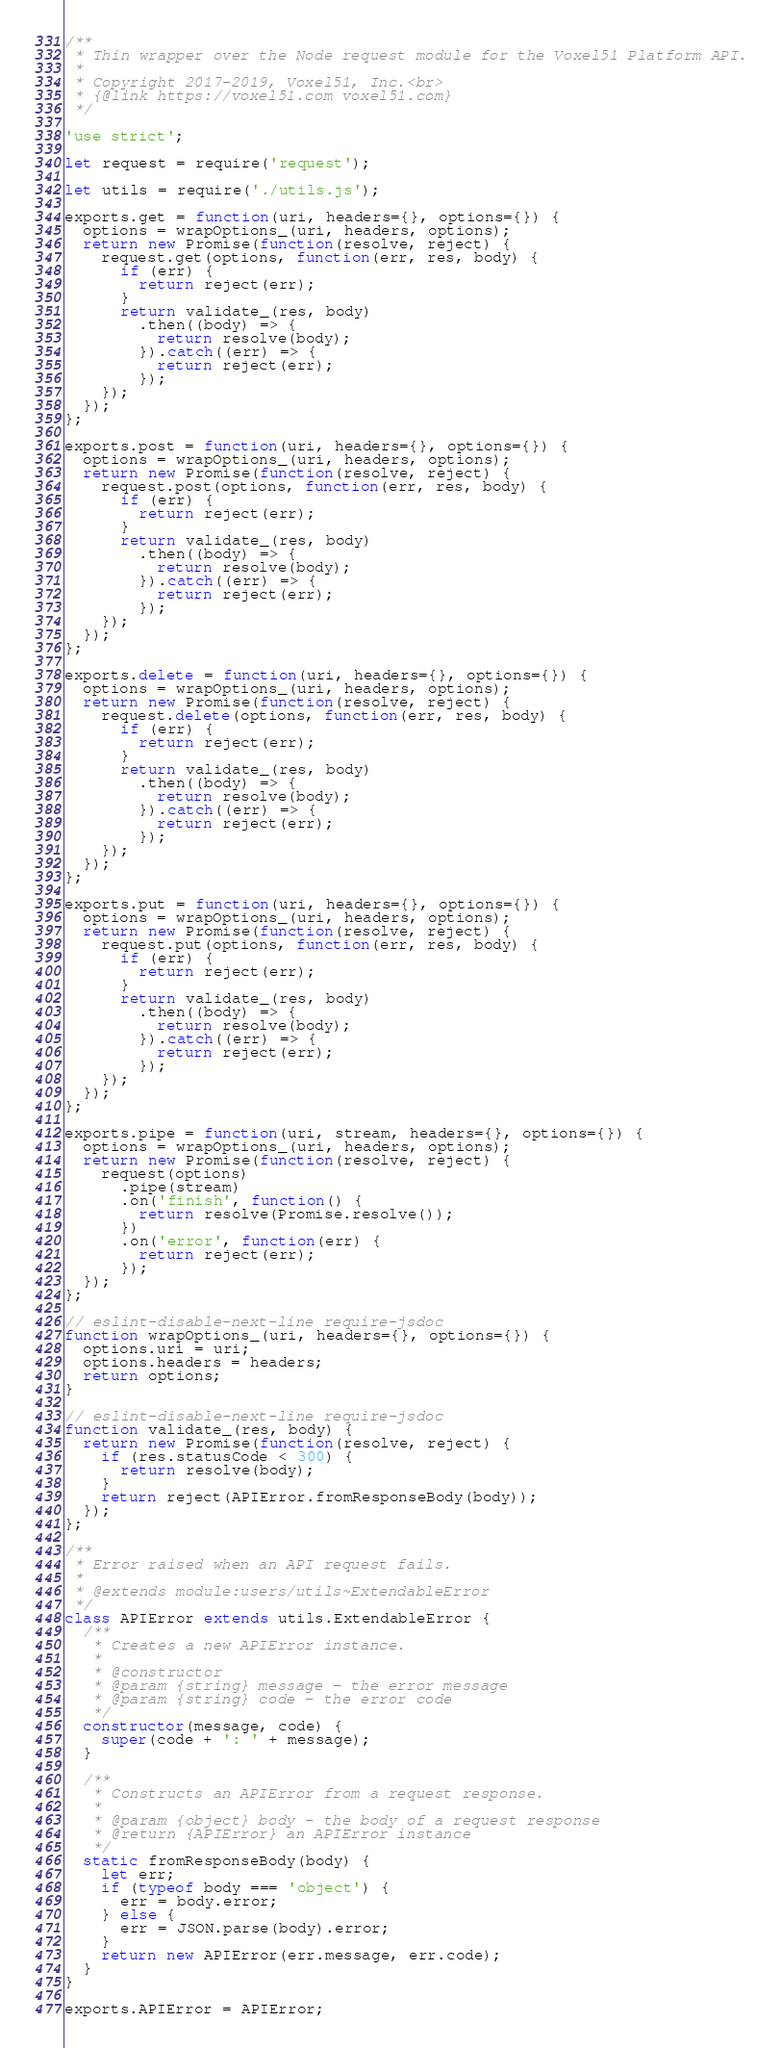<code> <loc_0><loc_0><loc_500><loc_500><_JavaScript_>/**
 * Thin wrapper over the Node request module for the Voxel51 Platform API.
 *
 * Copyright 2017-2019, Voxel51, Inc.<br>
 * {@link https://voxel51.com voxel51.com}
 */

'use strict';

let request = require('request');

let utils = require('./utils.js');

exports.get = function(uri, headers={}, options={}) {
  options = wrapOptions_(uri, headers, options);
  return new Promise(function(resolve, reject) {
    request.get(options, function(err, res, body) {
      if (err) {
        return reject(err);
      }
      return validate_(res, body)
        .then((body) => {
          return resolve(body);
        }).catch((err) => {
          return reject(err);
        });
    });
  });
};

exports.post = function(uri, headers={}, options={}) {
  options = wrapOptions_(uri, headers, options);
  return new Promise(function(resolve, reject) {
    request.post(options, function(err, res, body) {
      if (err) {
        return reject(err);
      }
      return validate_(res, body)
        .then((body) => {
          return resolve(body);
        }).catch((err) => {
          return reject(err);
        });
    });
  });
};

exports.delete = function(uri, headers={}, options={}) {
  options = wrapOptions_(uri, headers, options);
  return new Promise(function(resolve, reject) {
    request.delete(options, function(err, res, body) {
      if (err) {
        return reject(err);
      }
      return validate_(res, body)
        .then((body) => {
          return resolve(body);
        }).catch((err) => {
          return reject(err);
        });
    });
  });
};

exports.put = function(uri, headers={}, options={}) {
  options = wrapOptions_(uri, headers, options);
  return new Promise(function(resolve, reject) {
    request.put(options, function(err, res, body) {
      if (err) {
        return reject(err);
      }
      return validate_(res, body)
        .then((body) => {
          return resolve(body);
        }).catch((err) => {
          return reject(err);
        });
    });
  });
};

exports.pipe = function(uri, stream, headers={}, options={}) {
  options = wrapOptions_(uri, headers, options);
  return new Promise(function(resolve, reject) {
    request(options)
      .pipe(stream)
      .on('finish', function() {
        return resolve(Promise.resolve());
      })
      .on('error', function(err) {
        return reject(err);
      });
  });
};

// eslint-disable-next-line require-jsdoc
function wrapOptions_(uri, headers={}, options={}) {
  options.uri = uri;
  options.headers = headers;
  return options;
}

// eslint-disable-next-line require-jsdoc
function validate_(res, body) {
  return new Promise(function(resolve, reject) {
    if (res.statusCode < 300) {
      return resolve(body);
    }
    return reject(APIError.fromResponseBody(body));
  });
};

/**
 * Error raised when an API request fails.
 *
 * @extends module:users/utils~ExtendableError
 */
class APIError extends utils.ExtendableError {
  /**
   * Creates a new APIError instance.
   *
   * @constructor
   * @param {string} message - the error message
   * @param {string} code - the error code
   */
  constructor(message, code) {
    super(code + ': ' + message);
  }

  /**
   * Constructs an APIError from a request response.
   *
   * @param {object} body - the body of a request response
   * @return {APIError} an APIError instance
   */
  static fromResponseBody(body) {
    let err;
    if (typeof body === 'object') {
      err = body.error;
    } else {
      err = JSON.parse(body).error;
    }
    return new APIError(err.message, err.code);
  }
}

exports.APIError = APIError;
</code> 